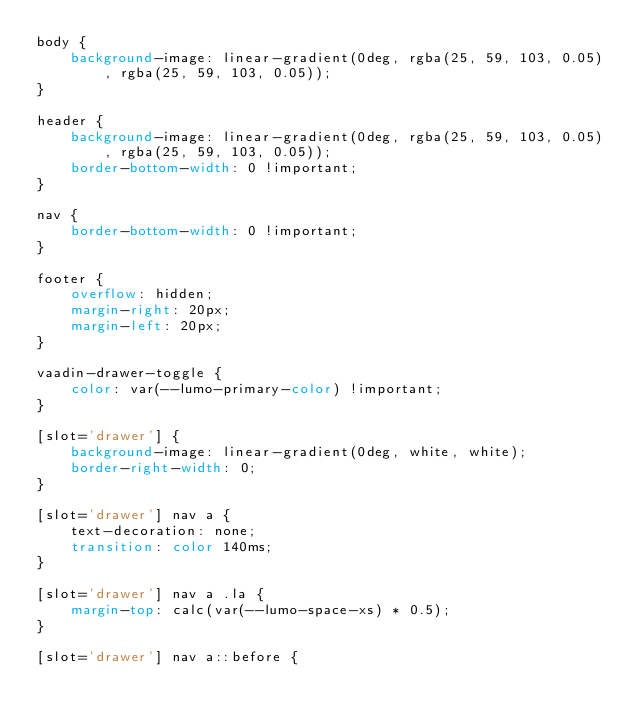<code> <loc_0><loc_0><loc_500><loc_500><_CSS_>body {
    background-image: linear-gradient(0deg, rgba(25, 59, 103, 0.05), rgba(25, 59, 103, 0.05));
}

header {
    background-image: linear-gradient(0deg, rgba(25, 59, 103, 0.05), rgba(25, 59, 103, 0.05));
    border-bottom-width: 0 !important;
}

nav {
    border-bottom-width: 0 !important;
}

footer {
    overflow: hidden;
    margin-right: 20px;
    margin-left: 20px;
}

vaadin-drawer-toggle {
    color: var(--lumo-primary-color) !important;
}

[slot='drawer'] {
    background-image: linear-gradient(0deg, white, white);
    border-right-width: 0;
}

[slot='drawer'] nav a {
    text-decoration: none;
    transition: color 140ms;
}

[slot='drawer'] nav a .la {
    margin-top: calc(var(--lumo-space-xs) * 0.5);
}

[slot='drawer'] nav a::before {</code> 